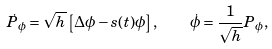Convert formula to latex. <formula><loc_0><loc_0><loc_500><loc_500>\dot { P } _ { \phi } = \sqrt { h } \left [ \Delta \phi - s ( t ) \phi \right ] , \quad \dot { \phi } = \frac { 1 } { \sqrt { h } } P _ { \phi } ,</formula> 